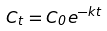<formula> <loc_0><loc_0><loc_500><loc_500>C _ { t } = C _ { 0 } e ^ { - k t }</formula> 